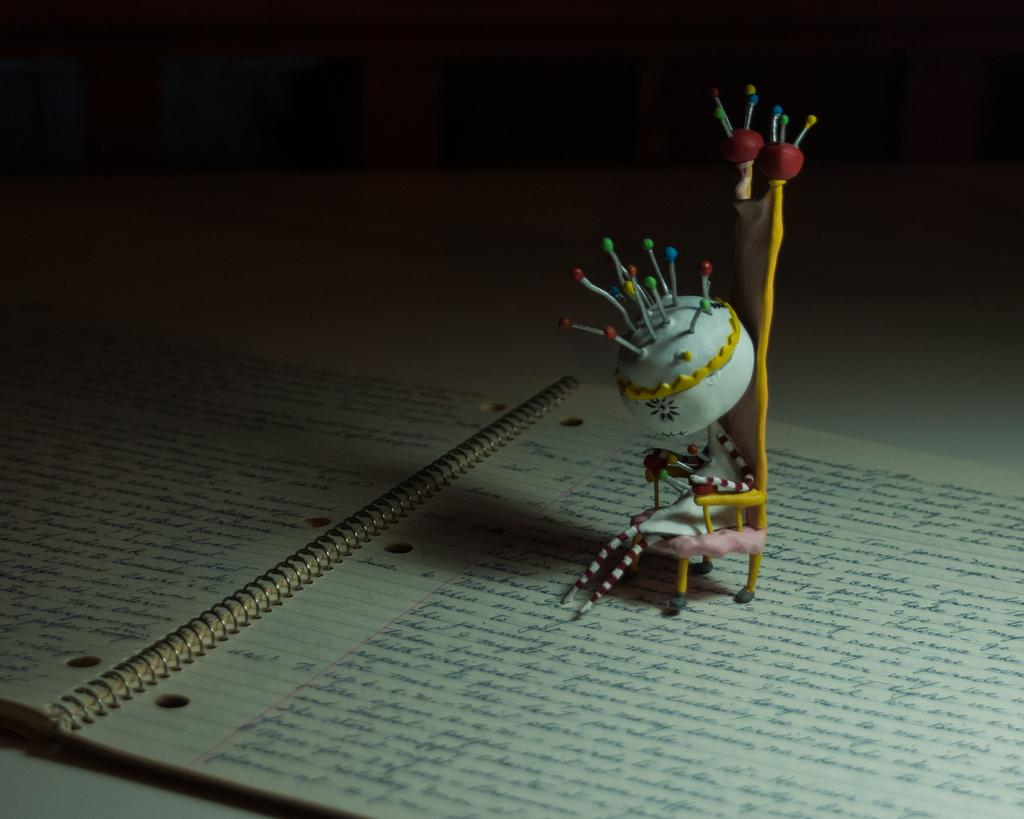What objects are placed on top of a book in the image? There are toys on a book in the image. What can be seen on the papers in the image? There is writing on the papers in the image. How would you describe the overall lighting in the image? The background of the image is dark. How many eyes can be seen on the toys in the image? There is no information about the number of eyes on the toys in the image, as the facts provided do not mention any specific details about the toys themselves. 